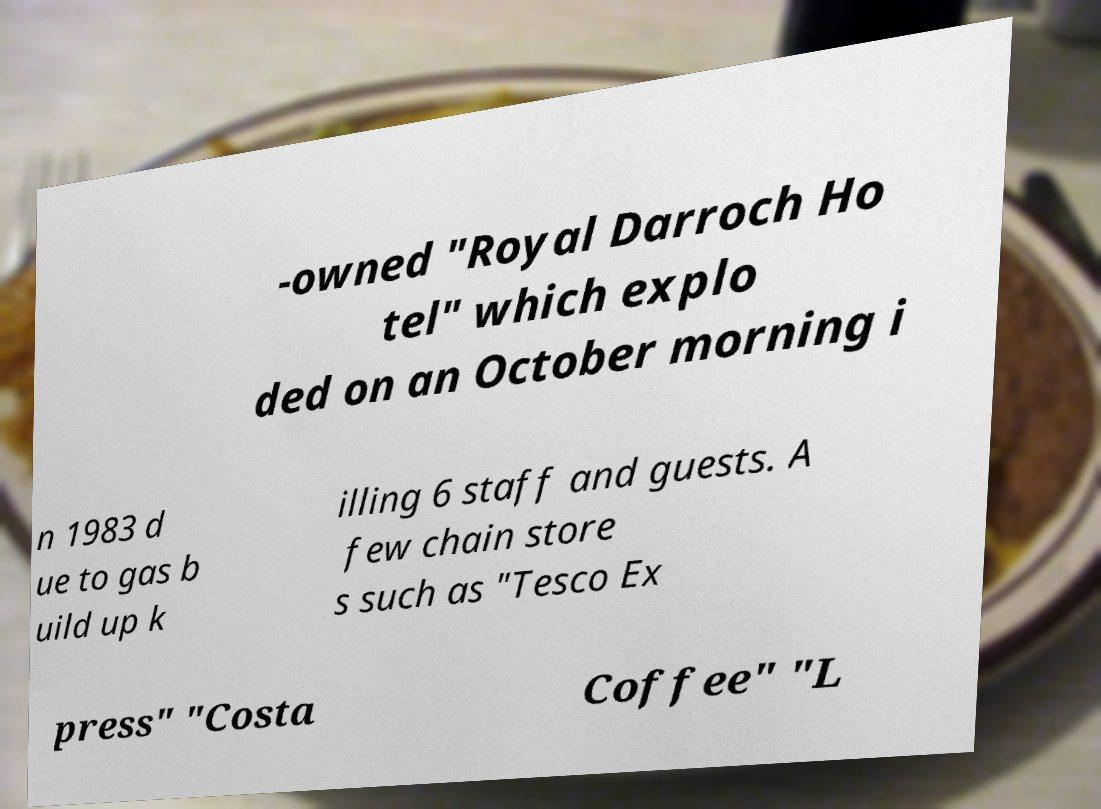I need the written content from this picture converted into text. Can you do that? -owned "Royal Darroch Ho tel" which explo ded on an October morning i n 1983 d ue to gas b uild up k illing 6 staff and guests. A few chain store s such as "Tesco Ex press" "Costa Coffee" "L 